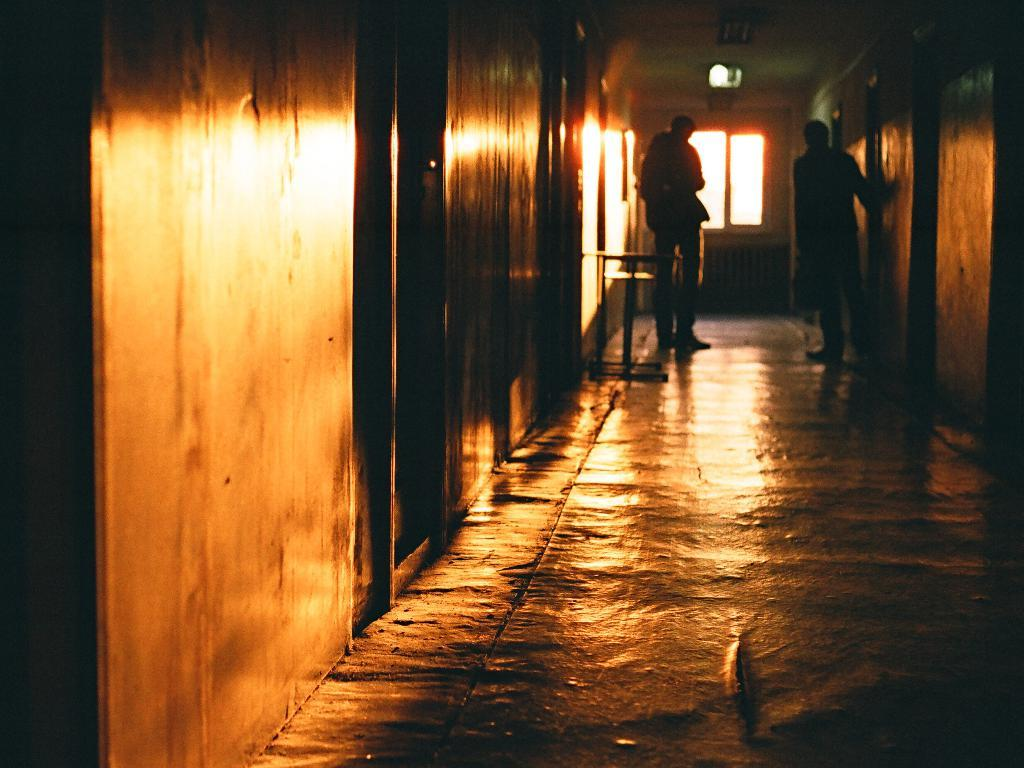How many people are in the image? There are two people standing in the image. Where are the people located? The people are in a corridor. What else can be seen in the corridor? There are doors visible in the image. Is there any source of natural light in the corridor? Yes, there is a window in the image. What type of mountain can be seen through the window in the image? There is no mountain visible through the window in the image. 